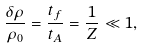<formula> <loc_0><loc_0><loc_500><loc_500>\frac { \delta \rho } { \rho _ { 0 } } = \frac { t _ { f } } { t _ { A } } = \frac { 1 } { Z } \ll 1 ,</formula> 